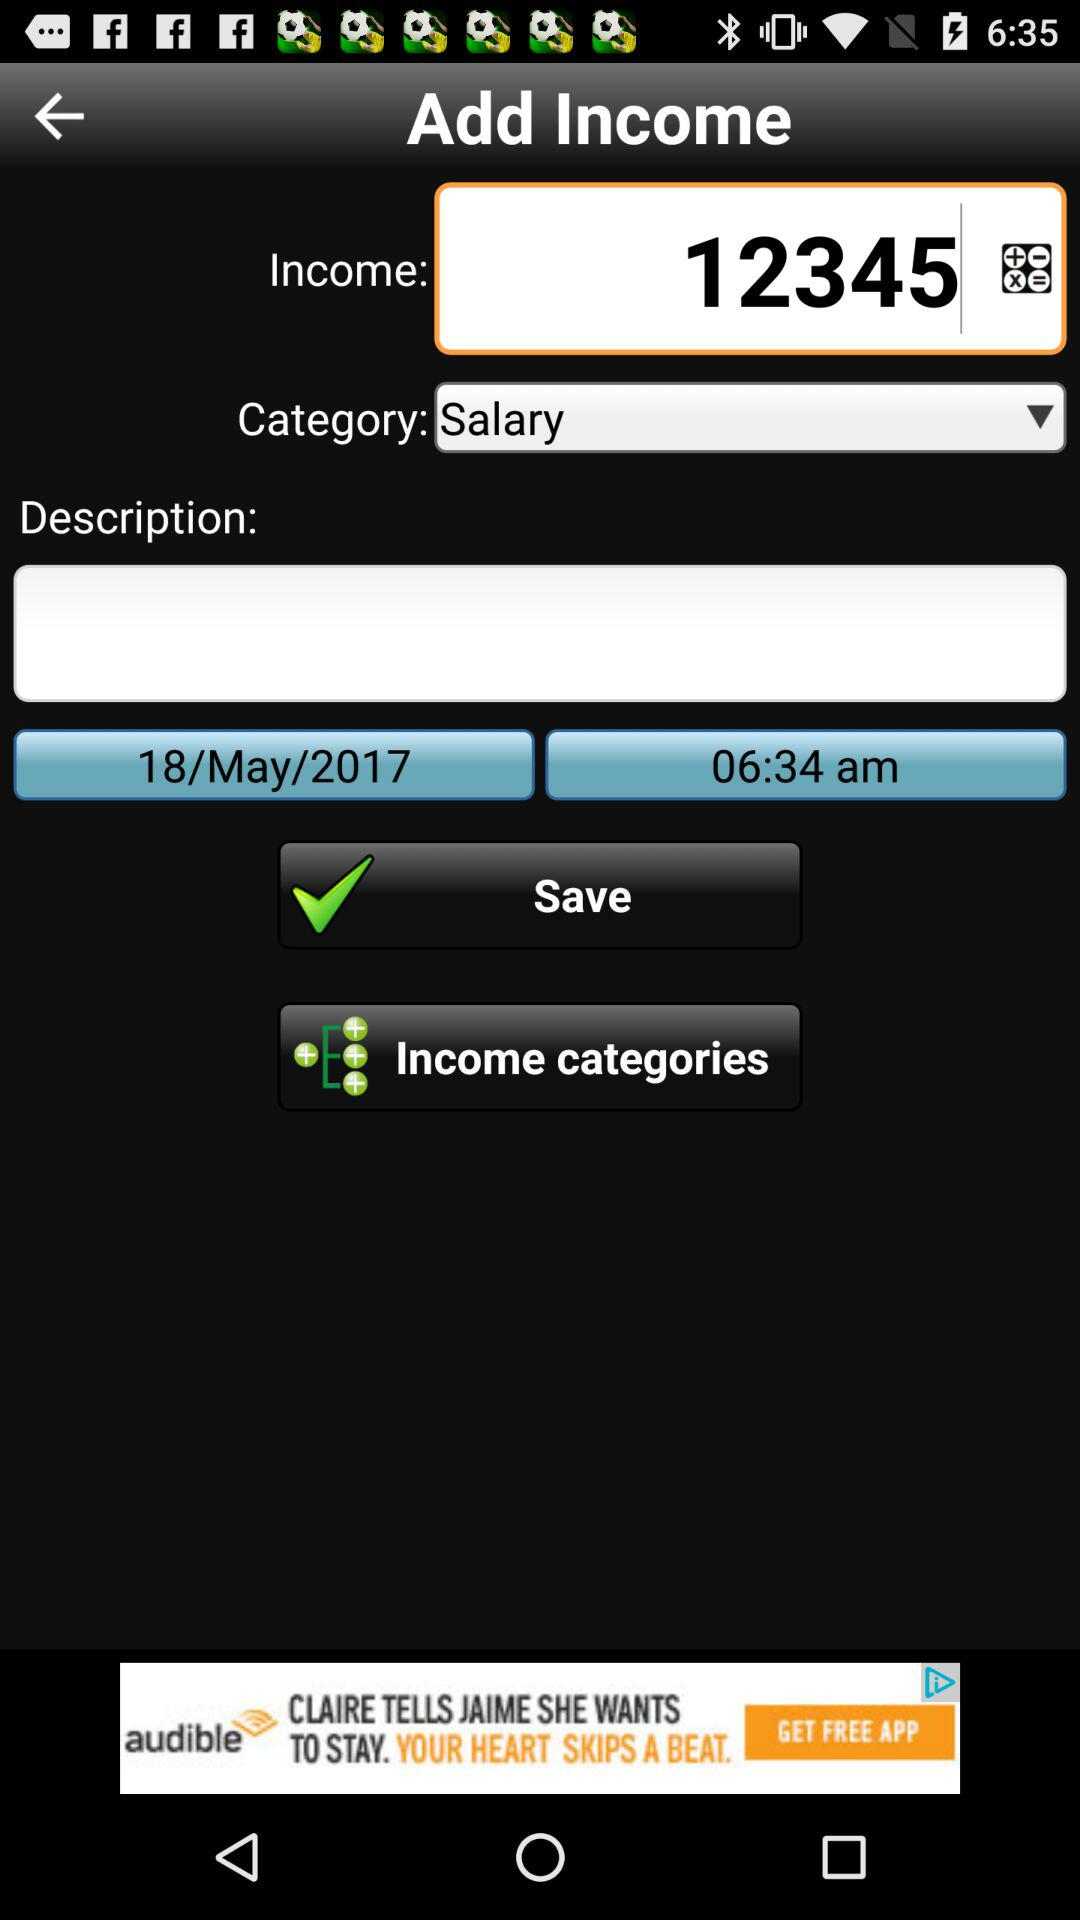What is the income shown on the screen? The income is 12345. 